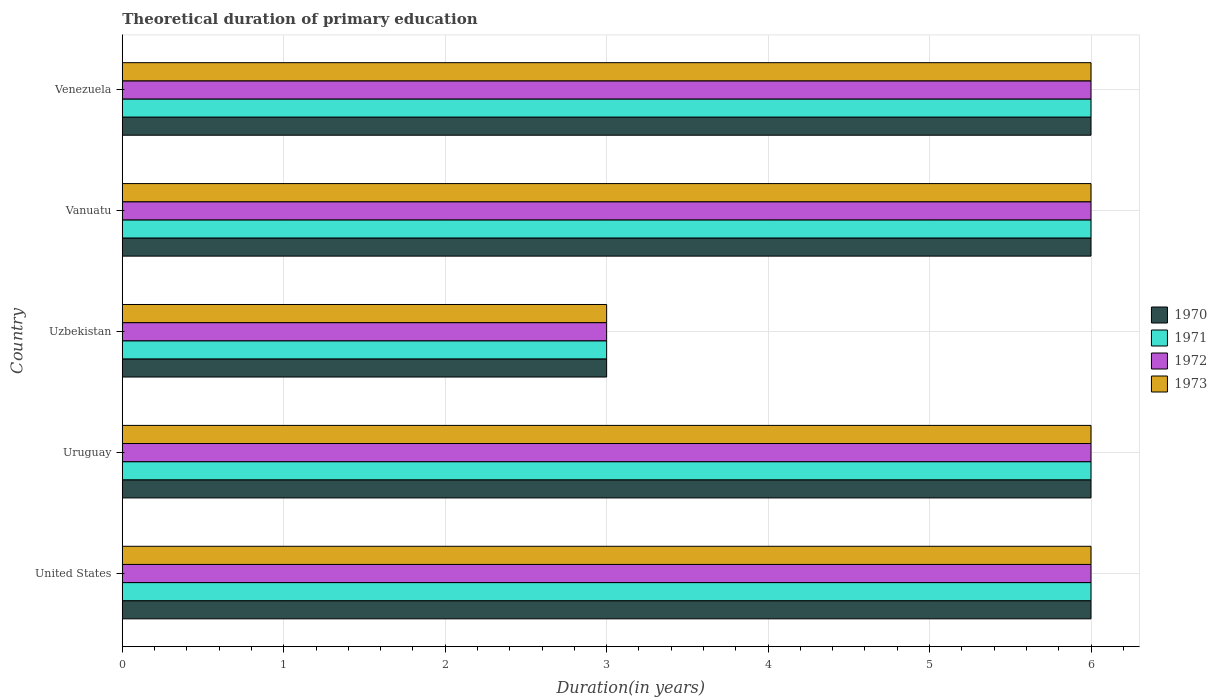How many groups of bars are there?
Provide a short and direct response. 5. How many bars are there on the 1st tick from the top?
Keep it short and to the point. 4. How many bars are there on the 5th tick from the bottom?
Your answer should be compact. 4. What is the label of the 4th group of bars from the top?
Keep it short and to the point. Uruguay. What is the total theoretical duration of primary education in 1973 in Uzbekistan?
Offer a very short reply. 3. Across all countries, what is the maximum total theoretical duration of primary education in 1973?
Make the answer very short. 6. In which country was the total theoretical duration of primary education in 1971 minimum?
Provide a succinct answer. Uzbekistan. What is the difference between the total theoretical duration of primary education in 1970 in United States and that in Uzbekistan?
Offer a terse response. 3. What is the difference between the total theoretical duration of primary education in 1972 and total theoretical duration of primary education in 1970 in Vanuatu?
Provide a short and direct response. 0. In how many countries, is the total theoretical duration of primary education in 1973 greater than 3.6 years?
Your response must be concise. 4. What is the ratio of the total theoretical duration of primary education in 1971 in United States to that in Vanuatu?
Your answer should be compact. 1. What is the difference between the highest and the lowest total theoretical duration of primary education in 1971?
Give a very brief answer. 3. Is the sum of the total theoretical duration of primary education in 1971 in United States and Uruguay greater than the maximum total theoretical duration of primary education in 1970 across all countries?
Keep it short and to the point. Yes. Is it the case that in every country, the sum of the total theoretical duration of primary education in 1973 and total theoretical duration of primary education in 1971 is greater than the sum of total theoretical duration of primary education in 1972 and total theoretical duration of primary education in 1970?
Your answer should be very brief. No. What does the 1st bar from the top in Venezuela represents?
Provide a succinct answer. 1973. How many countries are there in the graph?
Provide a short and direct response. 5. What is the difference between two consecutive major ticks on the X-axis?
Your answer should be compact. 1. Are the values on the major ticks of X-axis written in scientific E-notation?
Provide a short and direct response. No. Where does the legend appear in the graph?
Provide a succinct answer. Center right. What is the title of the graph?
Give a very brief answer. Theoretical duration of primary education. Does "2008" appear as one of the legend labels in the graph?
Provide a short and direct response. No. What is the label or title of the X-axis?
Your answer should be very brief. Duration(in years). What is the Duration(in years) in 1970 in United States?
Provide a succinct answer. 6. What is the Duration(in years) in 1971 in United States?
Provide a succinct answer. 6. What is the Duration(in years) of 1973 in United States?
Your answer should be very brief. 6. What is the Duration(in years) in 1970 in Uruguay?
Keep it short and to the point. 6. What is the Duration(in years) in 1971 in Uruguay?
Your answer should be very brief. 6. What is the Duration(in years) of 1973 in Uruguay?
Ensure brevity in your answer.  6. What is the Duration(in years) of 1971 in Uzbekistan?
Make the answer very short. 3. What is the Duration(in years) of 1973 in Uzbekistan?
Give a very brief answer. 3. What is the Duration(in years) in 1970 in Vanuatu?
Make the answer very short. 6. What is the Duration(in years) in 1971 in Vanuatu?
Ensure brevity in your answer.  6. What is the Duration(in years) of 1972 in Vanuatu?
Offer a terse response. 6. Across all countries, what is the maximum Duration(in years) of 1970?
Keep it short and to the point. 6. Across all countries, what is the maximum Duration(in years) in 1973?
Make the answer very short. 6. Across all countries, what is the minimum Duration(in years) of 1971?
Keep it short and to the point. 3. Across all countries, what is the minimum Duration(in years) of 1973?
Your response must be concise. 3. What is the total Duration(in years) of 1971 in the graph?
Make the answer very short. 27. What is the difference between the Duration(in years) of 1970 in United States and that in Uruguay?
Give a very brief answer. 0. What is the difference between the Duration(in years) of 1970 in United States and that in Uzbekistan?
Your answer should be compact. 3. What is the difference between the Duration(in years) in 1972 in United States and that in Uzbekistan?
Keep it short and to the point. 3. What is the difference between the Duration(in years) of 1973 in United States and that in Uzbekistan?
Give a very brief answer. 3. What is the difference between the Duration(in years) in 1970 in United States and that in Vanuatu?
Your answer should be compact. 0. What is the difference between the Duration(in years) in 1972 in United States and that in Vanuatu?
Provide a succinct answer. 0. What is the difference between the Duration(in years) in 1973 in United States and that in Vanuatu?
Provide a short and direct response. 0. What is the difference between the Duration(in years) of 1971 in United States and that in Venezuela?
Make the answer very short. 0. What is the difference between the Duration(in years) of 1972 in United States and that in Venezuela?
Provide a short and direct response. 0. What is the difference between the Duration(in years) in 1971 in Uruguay and that in Uzbekistan?
Ensure brevity in your answer.  3. What is the difference between the Duration(in years) of 1972 in Uruguay and that in Uzbekistan?
Your answer should be compact. 3. What is the difference between the Duration(in years) of 1973 in Uruguay and that in Uzbekistan?
Your answer should be very brief. 3. What is the difference between the Duration(in years) in 1970 in Uruguay and that in Vanuatu?
Provide a short and direct response. 0. What is the difference between the Duration(in years) of 1973 in Uruguay and that in Vanuatu?
Give a very brief answer. 0. What is the difference between the Duration(in years) in 1971 in Uruguay and that in Venezuela?
Your response must be concise. 0. What is the difference between the Duration(in years) in 1972 in Uruguay and that in Venezuela?
Offer a terse response. 0. What is the difference between the Duration(in years) in 1970 in Uzbekistan and that in Vanuatu?
Your response must be concise. -3. What is the difference between the Duration(in years) in 1971 in Uzbekistan and that in Vanuatu?
Offer a very short reply. -3. What is the difference between the Duration(in years) in 1970 in Uzbekistan and that in Venezuela?
Make the answer very short. -3. What is the difference between the Duration(in years) in 1972 in Uzbekistan and that in Venezuela?
Provide a short and direct response. -3. What is the difference between the Duration(in years) of 1970 in Vanuatu and that in Venezuela?
Your answer should be compact. 0. What is the difference between the Duration(in years) in 1972 in Vanuatu and that in Venezuela?
Provide a short and direct response. 0. What is the difference between the Duration(in years) in 1970 in United States and the Duration(in years) in 1971 in Uruguay?
Make the answer very short. 0. What is the difference between the Duration(in years) in 1970 in United States and the Duration(in years) in 1973 in Uruguay?
Offer a terse response. 0. What is the difference between the Duration(in years) in 1972 in United States and the Duration(in years) in 1973 in Uruguay?
Keep it short and to the point. 0. What is the difference between the Duration(in years) in 1970 in United States and the Duration(in years) in 1971 in Uzbekistan?
Offer a terse response. 3. What is the difference between the Duration(in years) in 1970 in United States and the Duration(in years) in 1973 in Uzbekistan?
Offer a terse response. 3. What is the difference between the Duration(in years) of 1971 in United States and the Duration(in years) of 1972 in Uzbekistan?
Ensure brevity in your answer.  3. What is the difference between the Duration(in years) in 1971 in United States and the Duration(in years) in 1973 in Uzbekistan?
Your response must be concise. 3. What is the difference between the Duration(in years) of 1972 in United States and the Duration(in years) of 1973 in Uzbekistan?
Offer a very short reply. 3. What is the difference between the Duration(in years) of 1970 in United States and the Duration(in years) of 1971 in Vanuatu?
Offer a terse response. 0. What is the difference between the Duration(in years) of 1970 in United States and the Duration(in years) of 1973 in Vanuatu?
Offer a terse response. 0. What is the difference between the Duration(in years) of 1971 in United States and the Duration(in years) of 1973 in Vanuatu?
Provide a succinct answer. 0. What is the difference between the Duration(in years) in 1970 in United States and the Duration(in years) in 1971 in Venezuela?
Your answer should be very brief. 0. What is the difference between the Duration(in years) in 1970 in United States and the Duration(in years) in 1972 in Venezuela?
Offer a terse response. 0. What is the difference between the Duration(in years) in 1970 in United States and the Duration(in years) in 1973 in Venezuela?
Your answer should be very brief. 0. What is the difference between the Duration(in years) in 1971 in United States and the Duration(in years) in 1973 in Venezuela?
Provide a succinct answer. 0. What is the difference between the Duration(in years) of 1970 in Uruguay and the Duration(in years) of 1971 in Uzbekistan?
Offer a terse response. 3. What is the difference between the Duration(in years) of 1970 in Uruguay and the Duration(in years) of 1972 in Uzbekistan?
Your response must be concise. 3. What is the difference between the Duration(in years) of 1971 in Uruguay and the Duration(in years) of 1972 in Uzbekistan?
Offer a very short reply. 3. What is the difference between the Duration(in years) of 1971 in Uruguay and the Duration(in years) of 1973 in Uzbekistan?
Your answer should be very brief. 3. What is the difference between the Duration(in years) in 1970 in Uruguay and the Duration(in years) in 1972 in Vanuatu?
Offer a terse response. 0. What is the difference between the Duration(in years) of 1970 in Uruguay and the Duration(in years) of 1973 in Vanuatu?
Your answer should be very brief. 0. What is the difference between the Duration(in years) in 1971 in Uruguay and the Duration(in years) in 1972 in Vanuatu?
Provide a succinct answer. 0. What is the difference between the Duration(in years) of 1971 in Uruguay and the Duration(in years) of 1973 in Vanuatu?
Keep it short and to the point. 0. What is the difference between the Duration(in years) in 1972 in Uruguay and the Duration(in years) in 1973 in Vanuatu?
Provide a short and direct response. 0. What is the difference between the Duration(in years) of 1970 in Uruguay and the Duration(in years) of 1972 in Venezuela?
Your answer should be very brief. 0. What is the difference between the Duration(in years) of 1970 in Uruguay and the Duration(in years) of 1973 in Venezuela?
Offer a terse response. 0. What is the difference between the Duration(in years) of 1970 in Uzbekistan and the Duration(in years) of 1972 in Vanuatu?
Give a very brief answer. -3. What is the difference between the Duration(in years) of 1971 in Uzbekistan and the Duration(in years) of 1972 in Vanuatu?
Provide a short and direct response. -3. What is the difference between the Duration(in years) in 1971 in Uzbekistan and the Duration(in years) in 1973 in Vanuatu?
Offer a terse response. -3. What is the difference between the Duration(in years) in 1972 in Uzbekistan and the Duration(in years) in 1973 in Vanuatu?
Offer a very short reply. -3. What is the difference between the Duration(in years) in 1971 in Uzbekistan and the Duration(in years) in 1973 in Venezuela?
Your response must be concise. -3. What is the difference between the Duration(in years) of 1970 in Vanuatu and the Duration(in years) of 1972 in Venezuela?
Provide a succinct answer. 0. What is the difference between the Duration(in years) of 1970 in Vanuatu and the Duration(in years) of 1973 in Venezuela?
Provide a short and direct response. 0. What is the difference between the Duration(in years) of 1971 in Vanuatu and the Duration(in years) of 1973 in Venezuela?
Ensure brevity in your answer.  0. What is the difference between the Duration(in years) in 1972 in Vanuatu and the Duration(in years) in 1973 in Venezuela?
Give a very brief answer. 0. What is the average Duration(in years) in 1970 per country?
Keep it short and to the point. 5.4. What is the average Duration(in years) of 1971 per country?
Offer a very short reply. 5.4. What is the average Duration(in years) of 1973 per country?
Give a very brief answer. 5.4. What is the difference between the Duration(in years) of 1970 and Duration(in years) of 1972 in United States?
Ensure brevity in your answer.  0. What is the difference between the Duration(in years) in 1971 and Duration(in years) in 1972 in United States?
Keep it short and to the point. 0. What is the difference between the Duration(in years) in 1971 and Duration(in years) in 1973 in United States?
Offer a terse response. 0. What is the difference between the Duration(in years) of 1970 and Duration(in years) of 1971 in Uruguay?
Provide a short and direct response. 0. What is the difference between the Duration(in years) of 1970 and Duration(in years) of 1972 in Uruguay?
Keep it short and to the point. 0. What is the difference between the Duration(in years) in 1971 and Duration(in years) in 1972 in Uruguay?
Ensure brevity in your answer.  0. What is the difference between the Duration(in years) in 1972 and Duration(in years) in 1973 in Uruguay?
Ensure brevity in your answer.  0. What is the difference between the Duration(in years) in 1970 and Duration(in years) in 1973 in Uzbekistan?
Make the answer very short. 0. What is the difference between the Duration(in years) of 1972 and Duration(in years) of 1973 in Uzbekistan?
Provide a short and direct response. 0. What is the difference between the Duration(in years) of 1970 and Duration(in years) of 1971 in Vanuatu?
Give a very brief answer. 0. What is the difference between the Duration(in years) of 1970 and Duration(in years) of 1972 in Vanuatu?
Give a very brief answer. 0. What is the difference between the Duration(in years) of 1970 and Duration(in years) of 1973 in Vanuatu?
Offer a very short reply. 0. What is the difference between the Duration(in years) of 1971 and Duration(in years) of 1973 in Vanuatu?
Make the answer very short. 0. What is the difference between the Duration(in years) in 1971 and Duration(in years) in 1972 in Venezuela?
Offer a terse response. 0. What is the difference between the Duration(in years) of 1972 and Duration(in years) of 1973 in Venezuela?
Offer a very short reply. 0. What is the ratio of the Duration(in years) in 1970 in United States to that in Uruguay?
Your answer should be compact. 1. What is the ratio of the Duration(in years) of 1973 in United States to that in Uruguay?
Your answer should be very brief. 1. What is the ratio of the Duration(in years) of 1970 in United States to that in Uzbekistan?
Provide a short and direct response. 2. What is the ratio of the Duration(in years) of 1971 in United States to that in Uzbekistan?
Your answer should be very brief. 2. What is the ratio of the Duration(in years) in 1973 in United States to that in Uzbekistan?
Keep it short and to the point. 2. What is the ratio of the Duration(in years) of 1970 in United States to that in Vanuatu?
Offer a terse response. 1. What is the ratio of the Duration(in years) of 1972 in United States to that in Vanuatu?
Offer a terse response. 1. What is the ratio of the Duration(in years) in 1970 in United States to that in Venezuela?
Provide a succinct answer. 1. What is the ratio of the Duration(in years) in 1972 in United States to that in Venezuela?
Provide a succinct answer. 1. What is the ratio of the Duration(in years) of 1973 in United States to that in Venezuela?
Offer a terse response. 1. What is the ratio of the Duration(in years) in 1971 in Uruguay to that in Uzbekistan?
Offer a terse response. 2. What is the ratio of the Duration(in years) in 1973 in Uruguay to that in Uzbekistan?
Your response must be concise. 2. What is the ratio of the Duration(in years) of 1970 in Uruguay to that in Vanuatu?
Your answer should be compact. 1. What is the ratio of the Duration(in years) in 1970 in Uruguay to that in Venezuela?
Offer a very short reply. 1. What is the ratio of the Duration(in years) of 1971 in Uruguay to that in Venezuela?
Ensure brevity in your answer.  1. What is the ratio of the Duration(in years) of 1973 in Uruguay to that in Venezuela?
Ensure brevity in your answer.  1. What is the ratio of the Duration(in years) in 1970 in Uzbekistan to that in Vanuatu?
Ensure brevity in your answer.  0.5. What is the ratio of the Duration(in years) in 1971 in Uzbekistan to that in Vanuatu?
Keep it short and to the point. 0.5. What is the ratio of the Duration(in years) of 1973 in Uzbekistan to that in Vanuatu?
Your response must be concise. 0.5. What is the ratio of the Duration(in years) in 1971 in Uzbekistan to that in Venezuela?
Keep it short and to the point. 0.5. What is the ratio of the Duration(in years) of 1972 in Uzbekistan to that in Venezuela?
Provide a short and direct response. 0.5. What is the ratio of the Duration(in years) in 1973 in Uzbekistan to that in Venezuela?
Ensure brevity in your answer.  0.5. What is the ratio of the Duration(in years) of 1971 in Vanuatu to that in Venezuela?
Your answer should be very brief. 1. What is the difference between the highest and the lowest Duration(in years) of 1970?
Offer a very short reply. 3. What is the difference between the highest and the lowest Duration(in years) of 1973?
Give a very brief answer. 3. 